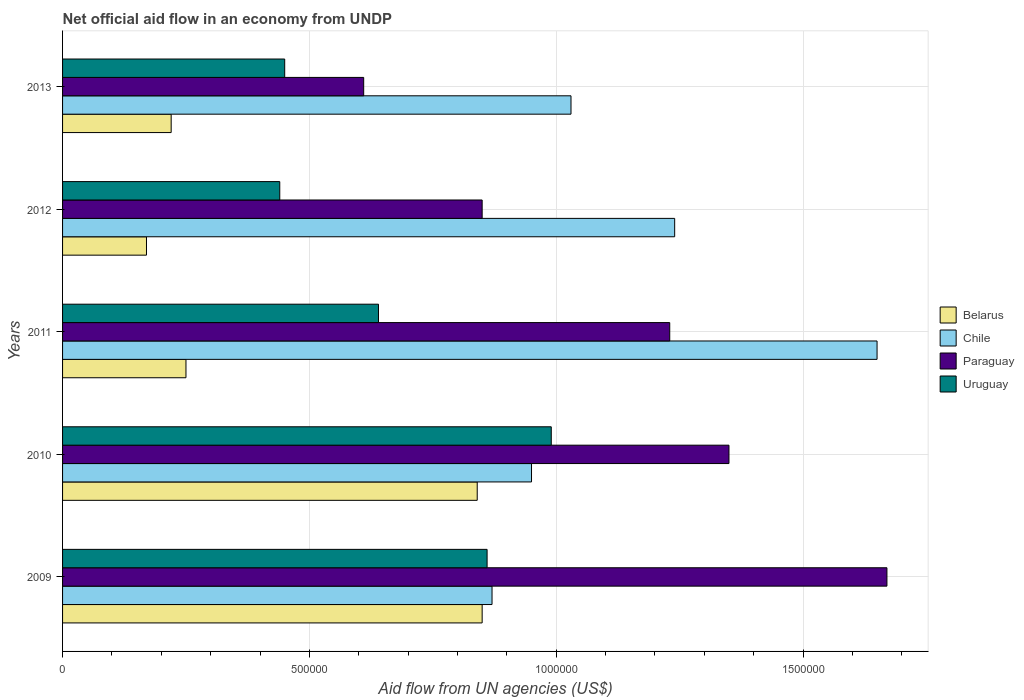How many different coloured bars are there?
Give a very brief answer. 4. How many groups of bars are there?
Ensure brevity in your answer.  5. Are the number of bars per tick equal to the number of legend labels?
Give a very brief answer. Yes. Are the number of bars on each tick of the Y-axis equal?
Provide a succinct answer. Yes. How many bars are there on the 2nd tick from the bottom?
Keep it short and to the point. 4. What is the label of the 1st group of bars from the top?
Ensure brevity in your answer.  2013. In how many cases, is the number of bars for a given year not equal to the number of legend labels?
Provide a succinct answer. 0. What is the net official aid flow in Chile in 2013?
Make the answer very short. 1.03e+06. Across all years, what is the maximum net official aid flow in Paraguay?
Offer a very short reply. 1.67e+06. Across all years, what is the minimum net official aid flow in Paraguay?
Give a very brief answer. 6.10e+05. In which year was the net official aid flow in Paraguay maximum?
Keep it short and to the point. 2009. What is the total net official aid flow in Uruguay in the graph?
Ensure brevity in your answer.  3.38e+06. What is the difference between the net official aid flow in Uruguay in 2009 and the net official aid flow in Chile in 2013?
Your response must be concise. -1.70e+05. What is the average net official aid flow in Chile per year?
Your response must be concise. 1.15e+06. In the year 2010, what is the difference between the net official aid flow in Belarus and net official aid flow in Paraguay?
Your answer should be very brief. -5.10e+05. In how many years, is the net official aid flow in Chile greater than 900000 US$?
Your response must be concise. 4. What is the ratio of the net official aid flow in Uruguay in 2009 to that in 2011?
Keep it short and to the point. 1.34. What is the difference between the highest and the second highest net official aid flow in Paraguay?
Give a very brief answer. 3.20e+05. What is the difference between the highest and the lowest net official aid flow in Paraguay?
Ensure brevity in your answer.  1.06e+06. In how many years, is the net official aid flow in Chile greater than the average net official aid flow in Chile taken over all years?
Your answer should be very brief. 2. Is it the case that in every year, the sum of the net official aid flow in Paraguay and net official aid flow in Uruguay is greater than the sum of net official aid flow in Chile and net official aid flow in Belarus?
Provide a succinct answer. No. What does the 2nd bar from the top in 2013 represents?
Provide a succinct answer. Paraguay. What does the 4th bar from the bottom in 2011 represents?
Your answer should be very brief. Uruguay. How many bars are there?
Provide a short and direct response. 20. What is the difference between two consecutive major ticks on the X-axis?
Your answer should be very brief. 5.00e+05. Does the graph contain any zero values?
Give a very brief answer. No. Does the graph contain grids?
Provide a succinct answer. Yes. What is the title of the graph?
Give a very brief answer. Net official aid flow in an economy from UNDP. Does "Middle East & North Africa (developing only)" appear as one of the legend labels in the graph?
Offer a very short reply. No. What is the label or title of the X-axis?
Your answer should be very brief. Aid flow from UN agencies (US$). What is the Aid flow from UN agencies (US$) in Belarus in 2009?
Provide a succinct answer. 8.50e+05. What is the Aid flow from UN agencies (US$) in Chile in 2009?
Offer a terse response. 8.70e+05. What is the Aid flow from UN agencies (US$) in Paraguay in 2009?
Keep it short and to the point. 1.67e+06. What is the Aid flow from UN agencies (US$) of Uruguay in 2009?
Your answer should be compact. 8.60e+05. What is the Aid flow from UN agencies (US$) in Belarus in 2010?
Keep it short and to the point. 8.40e+05. What is the Aid flow from UN agencies (US$) in Chile in 2010?
Your response must be concise. 9.50e+05. What is the Aid flow from UN agencies (US$) of Paraguay in 2010?
Your answer should be compact. 1.35e+06. What is the Aid flow from UN agencies (US$) in Uruguay in 2010?
Provide a short and direct response. 9.90e+05. What is the Aid flow from UN agencies (US$) of Chile in 2011?
Offer a terse response. 1.65e+06. What is the Aid flow from UN agencies (US$) of Paraguay in 2011?
Provide a short and direct response. 1.23e+06. What is the Aid flow from UN agencies (US$) in Uruguay in 2011?
Offer a terse response. 6.40e+05. What is the Aid flow from UN agencies (US$) in Belarus in 2012?
Provide a succinct answer. 1.70e+05. What is the Aid flow from UN agencies (US$) of Chile in 2012?
Keep it short and to the point. 1.24e+06. What is the Aid flow from UN agencies (US$) in Paraguay in 2012?
Ensure brevity in your answer.  8.50e+05. What is the Aid flow from UN agencies (US$) in Uruguay in 2012?
Give a very brief answer. 4.40e+05. What is the Aid flow from UN agencies (US$) of Chile in 2013?
Your answer should be very brief. 1.03e+06. What is the Aid flow from UN agencies (US$) in Uruguay in 2013?
Offer a terse response. 4.50e+05. Across all years, what is the maximum Aid flow from UN agencies (US$) in Belarus?
Ensure brevity in your answer.  8.50e+05. Across all years, what is the maximum Aid flow from UN agencies (US$) of Chile?
Offer a very short reply. 1.65e+06. Across all years, what is the maximum Aid flow from UN agencies (US$) of Paraguay?
Ensure brevity in your answer.  1.67e+06. Across all years, what is the maximum Aid flow from UN agencies (US$) of Uruguay?
Ensure brevity in your answer.  9.90e+05. Across all years, what is the minimum Aid flow from UN agencies (US$) in Chile?
Give a very brief answer. 8.70e+05. Across all years, what is the minimum Aid flow from UN agencies (US$) in Paraguay?
Ensure brevity in your answer.  6.10e+05. What is the total Aid flow from UN agencies (US$) of Belarus in the graph?
Keep it short and to the point. 2.33e+06. What is the total Aid flow from UN agencies (US$) in Chile in the graph?
Provide a succinct answer. 5.74e+06. What is the total Aid flow from UN agencies (US$) of Paraguay in the graph?
Make the answer very short. 5.71e+06. What is the total Aid flow from UN agencies (US$) in Uruguay in the graph?
Provide a short and direct response. 3.38e+06. What is the difference between the Aid flow from UN agencies (US$) of Belarus in 2009 and that in 2010?
Your answer should be very brief. 10000. What is the difference between the Aid flow from UN agencies (US$) in Paraguay in 2009 and that in 2010?
Provide a short and direct response. 3.20e+05. What is the difference between the Aid flow from UN agencies (US$) in Chile in 2009 and that in 2011?
Provide a short and direct response. -7.80e+05. What is the difference between the Aid flow from UN agencies (US$) in Paraguay in 2009 and that in 2011?
Make the answer very short. 4.40e+05. What is the difference between the Aid flow from UN agencies (US$) of Belarus in 2009 and that in 2012?
Make the answer very short. 6.80e+05. What is the difference between the Aid flow from UN agencies (US$) of Chile in 2009 and that in 2012?
Your answer should be very brief. -3.70e+05. What is the difference between the Aid flow from UN agencies (US$) of Paraguay in 2009 and that in 2012?
Make the answer very short. 8.20e+05. What is the difference between the Aid flow from UN agencies (US$) of Belarus in 2009 and that in 2013?
Make the answer very short. 6.30e+05. What is the difference between the Aid flow from UN agencies (US$) of Chile in 2009 and that in 2013?
Provide a short and direct response. -1.60e+05. What is the difference between the Aid flow from UN agencies (US$) in Paraguay in 2009 and that in 2013?
Provide a short and direct response. 1.06e+06. What is the difference between the Aid flow from UN agencies (US$) in Belarus in 2010 and that in 2011?
Ensure brevity in your answer.  5.90e+05. What is the difference between the Aid flow from UN agencies (US$) in Chile in 2010 and that in 2011?
Your response must be concise. -7.00e+05. What is the difference between the Aid flow from UN agencies (US$) in Belarus in 2010 and that in 2012?
Make the answer very short. 6.70e+05. What is the difference between the Aid flow from UN agencies (US$) in Chile in 2010 and that in 2012?
Offer a terse response. -2.90e+05. What is the difference between the Aid flow from UN agencies (US$) of Uruguay in 2010 and that in 2012?
Offer a terse response. 5.50e+05. What is the difference between the Aid flow from UN agencies (US$) in Belarus in 2010 and that in 2013?
Offer a terse response. 6.20e+05. What is the difference between the Aid flow from UN agencies (US$) of Chile in 2010 and that in 2013?
Offer a very short reply. -8.00e+04. What is the difference between the Aid flow from UN agencies (US$) of Paraguay in 2010 and that in 2013?
Offer a very short reply. 7.40e+05. What is the difference between the Aid flow from UN agencies (US$) in Uruguay in 2010 and that in 2013?
Your answer should be very brief. 5.40e+05. What is the difference between the Aid flow from UN agencies (US$) of Belarus in 2011 and that in 2012?
Provide a short and direct response. 8.00e+04. What is the difference between the Aid flow from UN agencies (US$) of Chile in 2011 and that in 2012?
Provide a succinct answer. 4.10e+05. What is the difference between the Aid flow from UN agencies (US$) in Paraguay in 2011 and that in 2012?
Provide a short and direct response. 3.80e+05. What is the difference between the Aid flow from UN agencies (US$) of Belarus in 2011 and that in 2013?
Give a very brief answer. 3.00e+04. What is the difference between the Aid flow from UN agencies (US$) in Chile in 2011 and that in 2013?
Your answer should be compact. 6.20e+05. What is the difference between the Aid flow from UN agencies (US$) of Paraguay in 2011 and that in 2013?
Make the answer very short. 6.20e+05. What is the difference between the Aid flow from UN agencies (US$) in Paraguay in 2012 and that in 2013?
Your response must be concise. 2.40e+05. What is the difference between the Aid flow from UN agencies (US$) of Uruguay in 2012 and that in 2013?
Your response must be concise. -10000. What is the difference between the Aid flow from UN agencies (US$) of Belarus in 2009 and the Aid flow from UN agencies (US$) of Paraguay in 2010?
Your response must be concise. -5.00e+05. What is the difference between the Aid flow from UN agencies (US$) of Belarus in 2009 and the Aid flow from UN agencies (US$) of Uruguay in 2010?
Give a very brief answer. -1.40e+05. What is the difference between the Aid flow from UN agencies (US$) in Chile in 2009 and the Aid flow from UN agencies (US$) in Paraguay in 2010?
Keep it short and to the point. -4.80e+05. What is the difference between the Aid flow from UN agencies (US$) in Paraguay in 2009 and the Aid flow from UN agencies (US$) in Uruguay in 2010?
Give a very brief answer. 6.80e+05. What is the difference between the Aid flow from UN agencies (US$) in Belarus in 2009 and the Aid flow from UN agencies (US$) in Chile in 2011?
Offer a very short reply. -8.00e+05. What is the difference between the Aid flow from UN agencies (US$) in Belarus in 2009 and the Aid flow from UN agencies (US$) in Paraguay in 2011?
Offer a very short reply. -3.80e+05. What is the difference between the Aid flow from UN agencies (US$) in Chile in 2009 and the Aid flow from UN agencies (US$) in Paraguay in 2011?
Make the answer very short. -3.60e+05. What is the difference between the Aid flow from UN agencies (US$) of Chile in 2009 and the Aid flow from UN agencies (US$) of Uruguay in 2011?
Provide a succinct answer. 2.30e+05. What is the difference between the Aid flow from UN agencies (US$) in Paraguay in 2009 and the Aid flow from UN agencies (US$) in Uruguay in 2011?
Provide a short and direct response. 1.03e+06. What is the difference between the Aid flow from UN agencies (US$) of Belarus in 2009 and the Aid flow from UN agencies (US$) of Chile in 2012?
Offer a very short reply. -3.90e+05. What is the difference between the Aid flow from UN agencies (US$) of Belarus in 2009 and the Aid flow from UN agencies (US$) of Paraguay in 2012?
Provide a succinct answer. 0. What is the difference between the Aid flow from UN agencies (US$) in Chile in 2009 and the Aid flow from UN agencies (US$) in Uruguay in 2012?
Make the answer very short. 4.30e+05. What is the difference between the Aid flow from UN agencies (US$) of Paraguay in 2009 and the Aid flow from UN agencies (US$) of Uruguay in 2012?
Ensure brevity in your answer.  1.23e+06. What is the difference between the Aid flow from UN agencies (US$) in Chile in 2009 and the Aid flow from UN agencies (US$) in Paraguay in 2013?
Offer a terse response. 2.60e+05. What is the difference between the Aid flow from UN agencies (US$) of Paraguay in 2009 and the Aid flow from UN agencies (US$) of Uruguay in 2013?
Provide a short and direct response. 1.22e+06. What is the difference between the Aid flow from UN agencies (US$) of Belarus in 2010 and the Aid flow from UN agencies (US$) of Chile in 2011?
Offer a terse response. -8.10e+05. What is the difference between the Aid flow from UN agencies (US$) in Belarus in 2010 and the Aid flow from UN agencies (US$) in Paraguay in 2011?
Offer a terse response. -3.90e+05. What is the difference between the Aid flow from UN agencies (US$) in Chile in 2010 and the Aid flow from UN agencies (US$) in Paraguay in 2011?
Make the answer very short. -2.80e+05. What is the difference between the Aid flow from UN agencies (US$) of Chile in 2010 and the Aid flow from UN agencies (US$) of Uruguay in 2011?
Your answer should be compact. 3.10e+05. What is the difference between the Aid flow from UN agencies (US$) in Paraguay in 2010 and the Aid flow from UN agencies (US$) in Uruguay in 2011?
Your answer should be very brief. 7.10e+05. What is the difference between the Aid flow from UN agencies (US$) in Belarus in 2010 and the Aid flow from UN agencies (US$) in Chile in 2012?
Offer a terse response. -4.00e+05. What is the difference between the Aid flow from UN agencies (US$) in Chile in 2010 and the Aid flow from UN agencies (US$) in Paraguay in 2012?
Your answer should be very brief. 1.00e+05. What is the difference between the Aid flow from UN agencies (US$) of Chile in 2010 and the Aid flow from UN agencies (US$) of Uruguay in 2012?
Offer a terse response. 5.10e+05. What is the difference between the Aid flow from UN agencies (US$) in Paraguay in 2010 and the Aid flow from UN agencies (US$) in Uruguay in 2012?
Your response must be concise. 9.10e+05. What is the difference between the Aid flow from UN agencies (US$) of Belarus in 2010 and the Aid flow from UN agencies (US$) of Chile in 2013?
Offer a terse response. -1.90e+05. What is the difference between the Aid flow from UN agencies (US$) in Chile in 2010 and the Aid flow from UN agencies (US$) in Uruguay in 2013?
Offer a terse response. 5.00e+05. What is the difference between the Aid flow from UN agencies (US$) in Paraguay in 2010 and the Aid flow from UN agencies (US$) in Uruguay in 2013?
Provide a short and direct response. 9.00e+05. What is the difference between the Aid flow from UN agencies (US$) in Belarus in 2011 and the Aid flow from UN agencies (US$) in Chile in 2012?
Your response must be concise. -9.90e+05. What is the difference between the Aid flow from UN agencies (US$) of Belarus in 2011 and the Aid flow from UN agencies (US$) of Paraguay in 2012?
Offer a terse response. -6.00e+05. What is the difference between the Aid flow from UN agencies (US$) in Belarus in 2011 and the Aid flow from UN agencies (US$) in Uruguay in 2012?
Make the answer very short. -1.90e+05. What is the difference between the Aid flow from UN agencies (US$) of Chile in 2011 and the Aid flow from UN agencies (US$) of Uruguay in 2012?
Ensure brevity in your answer.  1.21e+06. What is the difference between the Aid flow from UN agencies (US$) of Paraguay in 2011 and the Aid flow from UN agencies (US$) of Uruguay in 2012?
Provide a short and direct response. 7.90e+05. What is the difference between the Aid flow from UN agencies (US$) of Belarus in 2011 and the Aid flow from UN agencies (US$) of Chile in 2013?
Make the answer very short. -7.80e+05. What is the difference between the Aid flow from UN agencies (US$) of Belarus in 2011 and the Aid flow from UN agencies (US$) of Paraguay in 2013?
Offer a very short reply. -3.60e+05. What is the difference between the Aid flow from UN agencies (US$) of Belarus in 2011 and the Aid flow from UN agencies (US$) of Uruguay in 2013?
Provide a short and direct response. -2.00e+05. What is the difference between the Aid flow from UN agencies (US$) of Chile in 2011 and the Aid flow from UN agencies (US$) of Paraguay in 2013?
Provide a short and direct response. 1.04e+06. What is the difference between the Aid flow from UN agencies (US$) in Chile in 2011 and the Aid flow from UN agencies (US$) in Uruguay in 2013?
Keep it short and to the point. 1.20e+06. What is the difference between the Aid flow from UN agencies (US$) in Paraguay in 2011 and the Aid flow from UN agencies (US$) in Uruguay in 2013?
Your answer should be very brief. 7.80e+05. What is the difference between the Aid flow from UN agencies (US$) of Belarus in 2012 and the Aid flow from UN agencies (US$) of Chile in 2013?
Your answer should be compact. -8.60e+05. What is the difference between the Aid flow from UN agencies (US$) of Belarus in 2012 and the Aid flow from UN agencies (US$) of Paraguay in 2013?
Offer a very short reply. -4.40e+05. What is the difference between the Aid flow from UN agencies (US$) in Belarus in 2012 and the Aid flow from UN agencies (US$) in Uruguay in 2013?
Provide a succinct answer. -2.80e+05. What is the difference between the Aid flow from UN agencies (US$) in Chile in 2012 and the Aid flow from UN agencies (US$) in Paraguay in 2013?
Provide a succinct answer. 6.30e+05. What is the difference between the Aid flow from UN agencies (US$) in Chile in 2012 and the Aid flow from UN agencies (US$) in Uruguay in 2013?
Provide a succinct answer. 7.90e+05. What is the average Aid flow from UN agencies (US$) in Belarus per year?
Your answer should be compact. 4.66e+05. What is the average Aid flow from UN agencies (US$) of Chile per year?
Offer a terse response. 1.15e+06. What is the average Aid flow from UN agencies (US$) of Paraguay per year?
Your answer should be compact. 1.14e+06. What is the average Aid flow from UN agencies (US$) of Uruguay per year?
Ensure brevity in your answer.  6.76e+05. In the year 2009, what is the difference between the Aid flow from UN agencies (US$) in Belarus and Aid flow from UN agencies (US$) in Chile?
Make the answer very short. -2.00e+04. In the year 2009, what is the difference between the Aid flow from UN agencies (US$) of Belarus and Aid flow from UN agencies (US$) of Paraguay?
Make the answer very short. -8.20e+05. In the year 2009, what is the difference between the Aid flow from UN agencies (US$) of Belarus and Aid flow from UN agencies (US$) of Uruguay?
Keep it short and to the point. -10000. In the year 2009, what is the difference between the Aid flow from UN agencies (US$) in Chile and Aid flow from UN agencies (US$) in Paraguay?
Offer a terse response. -8.00e+05. In the year 2009, what is the difference between the Aid flow from UN agencies (US$) in Paraguay and Aid flow from UN agencies (US$) in Uruguay?
Provide a short and direct response. 8.10e+05. In the year 2010, what is the difference between the Aid flow from UN agencies (US$) of Belarus and Aid flow from UN agencies (US$) of Chile?
Make the answer very short. -1.10e+05. In the year 2010, what is the difference between the Aid flow from UN agencies (US$) in Belarus and Aid flow from UN agencies (US$) in Paraguay?
Make the answer very short. -5.10e+05. In the year 2010, what is the difference between the Aid flow from UN agencies (US$) in Chile and Aid flow from UN agencies (US$) in Paraguay?
Ensure brevity in your answer.  -4.00e+05. In the year 2011, what is the difference between the Aid flow from UN agencies (US$) of Belarus and Aid flow from UN agencies (US$) of Chile?
Give a very brief answer. -1.40e+06. In the year 2011, what is the difference between the Aid flow from UN agencies (US$) of Belarus and Aid flow from UN agencies (US$) of Paraguay?
Give a very brief answer. -9.80e+05. In the year 2011, what is the difference between the Aid flow from UN agencies (US$) of Belarus and Aid flow from UN agencies (US$) of Uruguay?
Give a very brief answer. -3.90e+05. In the year 2011, what is the difference between the Aid flow from UN agencies (US$) of Chile and Aid flow from UN agencies (US$) of Paraguay?
Your answer should be very brief. 4.20e+05. In the year 2011, what is the difference between the Aid flow from UN agencies (US$) in Chile and Aid flow from UN agencies (US$) in Uruguay?
Offer a very short reply. 1.01e+06. In the year 2011, what is the difference between the Aid flow from UN agencies (US$) in Paraguay and Aid flow from UN agencies (US$) in Uruguay?
Offer a terse response. 5.90e+05. In the year 2012, what is the difference between the Aid flow from UN agencies (US$) in Belarus and Aid flow from UN agencies (US$) in Chile?
Offer a very short reply. -1.07e+06. In the year 2012, what is the difference between the Aid flow from UN agencies (US$) in Belarus and Aid flow from UN agencies (US$) in Paraguay?
Keep it short and to the point. -6.80e+05. In the year 2012, what is the difference between the Aid flow from UN agencies (US$) of Chile and Aid flow from UN agencies (US$) of Paraguay?
Provide a succinct answer. 3.90e+05. In the year 2012, what is the difference between the Aid flow from UN agencies (US$) in Paraguay and Aid flow from UN agencies (US$) in Uruguay?
Offer a terse response. 4.10e+05. In the year 2013, what is the difference between the Aid flow from UN agencies (US$) of Belarus and Aid flow from UN agencies (US$) of Chile?
Keep it short and to the point. -8.10e+05. In the year 2013, what is the difference between the Aid flow from UN agencies (US$) in Belarus and Aid flow from UN agencies (US$) in Paraguay?
Your answer should be very brief. -3.90e+05. In the year 2013, what is the difference between the Aid flow from UN agencies (US$) in Chile and Aid flow from UN agencies (US$) in Paraguay?
Your response must be concise. 4.20e+05. In the year 2013, what is the difference between the Aid flow from UN agencies (US$) of Chile and Aid flow from UN agencies (US$) of Uruguay?
Provide a succinct answer. 5.80e+05. In the year 2013, what is the difference between the Aid flow from UN agencies (US$) of Paraguay and Aid flow from UN agencies (US$) of Uruguay?
Your response must be concise. 1.60e+05. What is the ratio of the Aid flow from UN agencies (US$) of Belarus in 2009 to that in 2010?
Make the answer very short. 1.01. What is the ratio of the Aid flow from UN agencies (US$) of Chile in 2009 to that in 2010?
Provide a short and direct response. 0.92. What is the ratio of the Aid flow from UN agencies (US$) in Paraguay in 2009 to that in 2010?
Your answer should be very brief. 1.24. What is the ratio of the Aid flow from UN agencies (US$) of Uruguay in 2009 to that in 2010?
Your answer should be very brief. 0.87. What is the ratio of the Aid flow from UN agencies (US$) in Chile in 2009 to that in 2011?
Give a very brief answer. 0.53. What is the ratio of the Aid flow from UN agencies (US$) of Paraguay in 2009 to that in 2011?
Offer a very short reply. 1.36. What is the ratio of the Aid flow from UN agencies (US$) of Uruguay in 2009 to that in 2011?
Your answer should be very brief. 1.34. What is the ratio of the Aid flow from UN agencies (US$) in Chile in 2009 to that in 2012?
Give a very brief answer. 0.7. What is the ratio of the Aid flow from UN agencies (US$) of Paraguay in 2009 to that in 2012?
Offer a very short reply. 1.96. What is the ratio of the Aid flow from UN agencies (US$) in Uruguay in 2009 to that in 2012?
Provide a succinct answer. 1.95. What is the ratio of the Aid flow from UN agencies (US$) in Belarus in 2009 to that in 2013?
Offer a very short reply. 3.86. What is the ratio of the Aid flow from UN agencies (US$) in Chile in 2009 to that in 2013?
Your answer should be very brief. 0.84. What is the ratio of the Aid flow from UN agencies (US$) in Paraguay in 2009 to that in 2013?
Ensure brevity in your answer.  2.74. What is the ratio of the Aid flow from UN agencies (US$) of Uruguay in 2009 to that in 2013?
Make the answer very short. 1.91. What is the ratio of the Aid flow from UN agencies (US$) of Belarus in 2010 to that in 2011?
Ensure brevity in your answer.  3.36. What is the ratio of the Aid flow from UN agencies (US$) in Chile in 2010 to that in 2011?
Give a very brief answer. 0.58. What is the ratio of the Aid flow from UN agencies (US$) of Paraguay in 2010 to that in 2011?
Ensure brevity in your answer.  1.1. What is the ratio of the Aid flow from UN agencies (US$) in Uruguay in 2010 to that in 2011?
Offer a very short reply. 1.55. What is the ratio of the Aid flow from UN agencies (US$) in Belarus in 2010 to that in 2012?
Offer a terse response. 4.94. What is the ratio of the Aid flow from UN agencies (US$) of Chile in 2010 to that in 2012?
Your answer should be compact. 0.77. What is the ratio of the Aid flow from UN agencies (US$) in Paraguay in 2010 to that in 2012?
Offer a terse response. 1.59. What is the ratio of the Aid flow from UN agencies (US$) in Uruguay in 2010 to that in 2012?
Offer a very short reply. 2.25. What is the ratio of the Aid flow from UN agencies (US$) of Belarus in 2010 to that in 2013?
Provide a succinct answer. 3.82. What is the ratio of the Aid flow from UN agencies (US$) of Chile in 2010 to that in 2013?
Offer a terse response. 0.92. What is the ratio of the Aid flow from UN agencies (US$) in Paraguay in 2010 to that in 2013?
Your answer should be compact. 2.21. What is the ratio of the Aid flow from UN agencies (US$) in Uruguay in 2010 to that in 2013?
Provide a succinct answer. 2.2. What is the ratio of the Aid flow from UN agencies (US$) of Belarus in 2011 to that in 2012?
Ensure brevity in your answer.  1.47. What is the ratio of the Aid flow from UN agencies (US$) of Chile in 2011 to that in 2012?
Provide a short and direct response. 1.33. What is the ratio of the Aid flow from UN agencies (US$) in Paraguay in 2011 to that in 2012?
Your answer should be very brief. 1.45. What is the ratio of the Aid flow from UN agencies (US$) in Uruguay in 2011 to that in 2012?
Ensure brevity in your answer.  1.45. What is the ratio of the Aid flow from UN agencies (US$) of Belarus in 2011 to that in 2013?
Provide a short and direct response. 1.14. What is the ratio of the Aid flow from UN agencies (US$) in Chile in 2011 to that in 2013?
Offer a very short reply. 1.6. What is the ratio of the Aid flow from UN agencies (US$) in Paraguay in 2011 to that in 2013?
Offer a very short reply. 2.02. What is the ratio of the Aid flow from UN agencies (US$) in Uruguay in 2011 to that in 2013?
Give a very brief answer. 1.42. What is the ratio of the Aid flow from UN agencies (US$) in Belarus in 2012 to that in 2013?
Keep it short and to the point. 0.77. What is the ratio of the Aid flow from UN agencies (US$) of Chile in 2012 to that in 2013?
Offer a terse response. 1.2. What is the ratio of the Aid flow from UN agencies (US$) in Paraguay in 2012 to that in 2013?
Provide a short and direct response. 1.39. What is the ratio of the Aid flow from UN agencies (US$) in Uruguay in 2012 to that in 2013?
Your answer should be very brief. 0.98. What is the difference between the highest and the second highest Aid flow from UN agencies (US$) in Chile?
Give a very brief answer. 4.10e+05. What is the difference between the highest and the second highest Aid flow from UN agencies (US$) of Paraguay?
Give a very brief answer. 3.20e+05. What is the difference between the highest and the lowest Aid flow from UN agencies (US$) in Belarus?
Give a very brief answer. 6.80e+05. What is the difference between the highest and the lowest Aid flow from UN agencies (US$) in Chile?
Give a very brief answer. 7.80e+05. What is the difference between the highest and the lowest Aid flow from UN agencies (US$) of Paraguay?
Provide a succinct answer. 1.06e+06. 